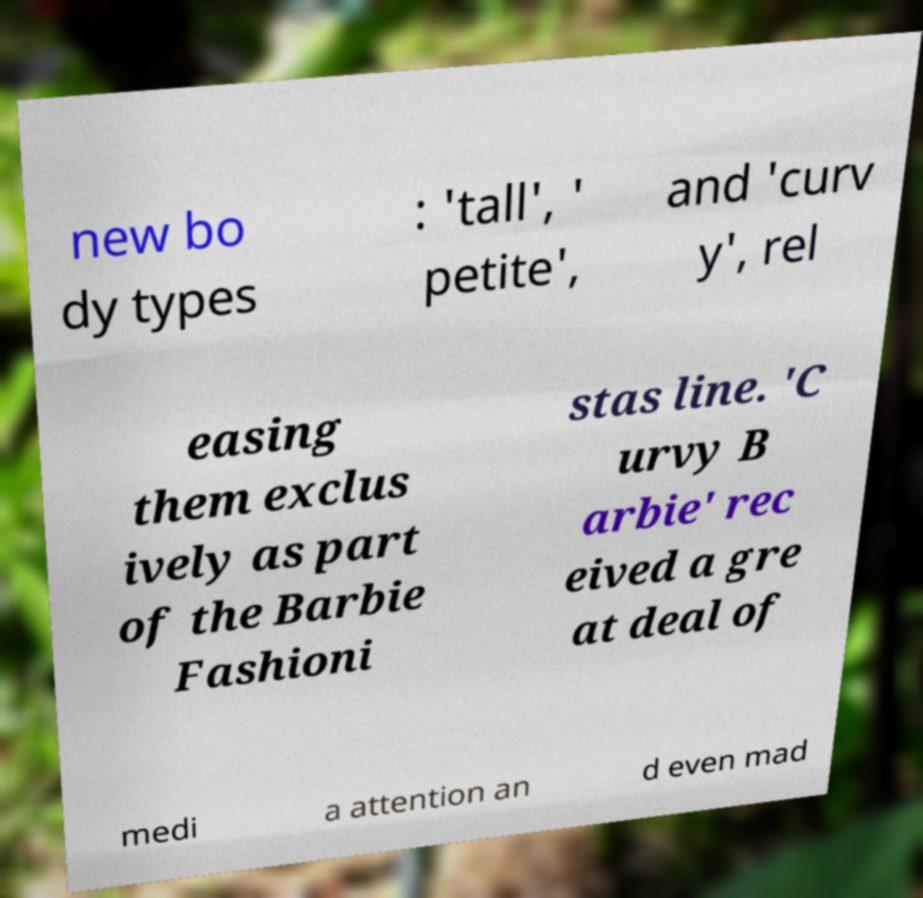Can you accurately transcribe the text from the provided image for me? new bo dy types : 'tall', ' petite', and 'curv y', rel easing them exclus ively as part of the Barbie Fashioni stas line. 'C urvy B arbie' rec eived a gre at deal of medi a attention an d even mad 